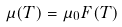<formula> <loc_0><loc_0><loc_500><loc_500>\mu ( T ) = \mu _ { 0 } F ( T )</formula> 